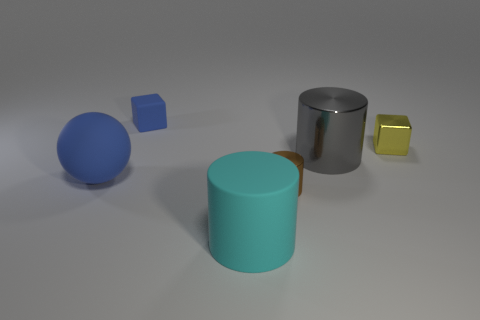Add 1 small balls. How many objects exist? 7 Subtract all cubes. How many objects are left? 4 Add 1 small shiny things. How many small shiny things exist? 3 Subtract 1 brown cylinders. How many objects are left? 5 Subtract all small blue rubber blocks. Subtract all cubes. How many objects are left? 3 Add 3 tiny cylinders. How many tiny cylinders are left? 4 